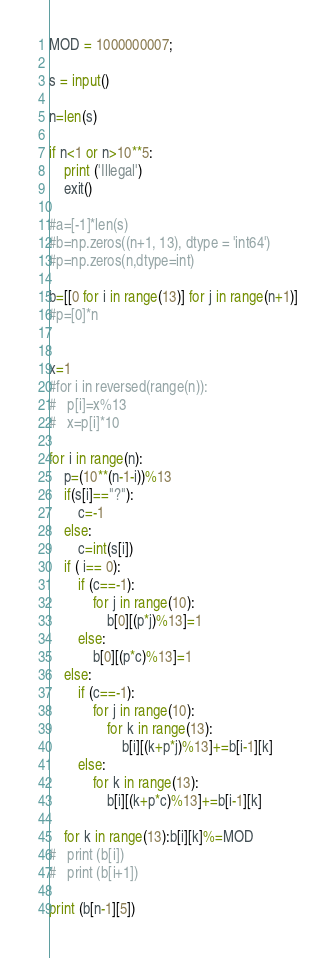<code> <loc_0><loc_0><loc_500><loc_500><_Python_>
MOD = 1000000007;

s = input()

n=len(s)

if n<1 or n>10**5:
	print ('Illegal')
	exit()

#a=[-1]*len(s)
#b=np.zeros((n+1, 13), dtype = 'int64')
#p=np.zeros(n,dtype=int)

b=[[0 for i in range(13)] for j in range(n+1)]
#p=[0]*n


x=1
#for i in reversed(range(n)):
#	p[i]=x%13
#	x=p[i]*10
	
for i in range(n):
	p=(10**(n-1-i))%13
	if(s[i]=="?"):
		c=-1
	else:
		c=int(s[i])
	if ( i== 0):
		if (c==-1):
			for j in range(10):
				b[0][(p*j)%13]=1
		else:
			b[0][(p*c)%13]=1
	else:
		if (c==-1):
			for j in range(10):
				for k in range(13):
					b[i][(k+p*j)%13]+=b[i-1][k]
		else:
			for k in range(13):
				b[i][(k+p*c)%13]+=b[i-1][k]

	for k in range(13):b[i][k]%=MOD
#	print (b[i])
#	print (b[i+1])

print (b[n-1][5])

</code> 